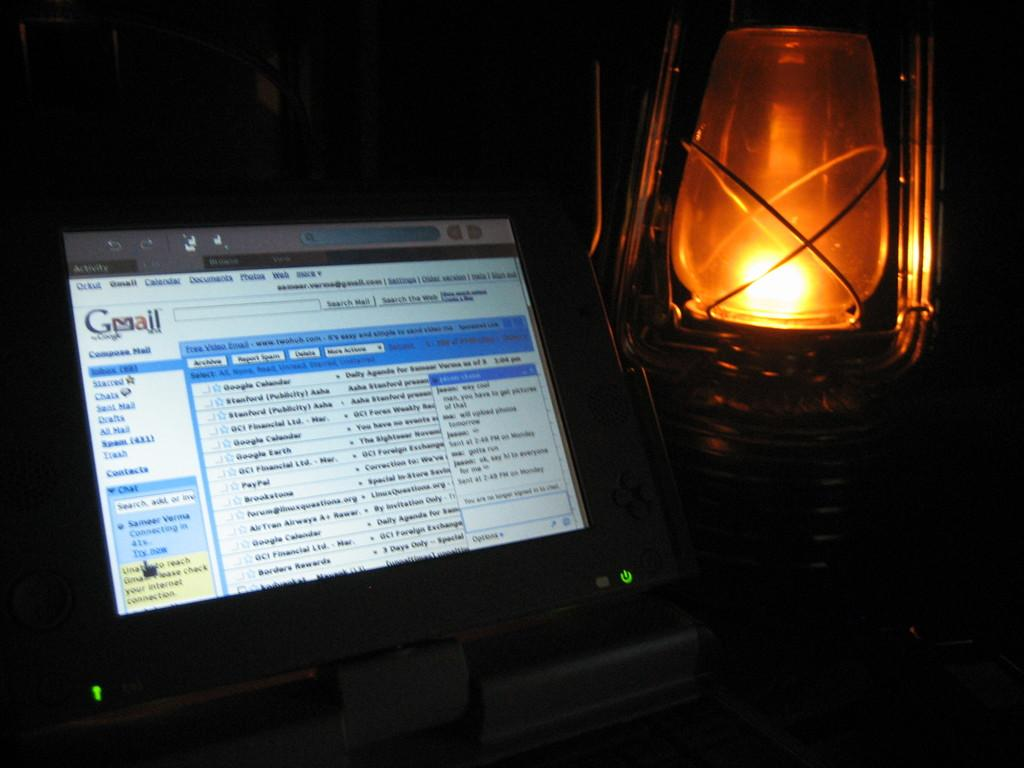What electronic device is visible in the image? There is a monitor in the image. What type of lighting source is present in the image? There is a lantern in the image. How would you describe the overall lighting in the image? The background of the image is dark. What decision was made by the person holding the lantern in the image? There is no person holding the lantern in the image, and therefore no decision can be attributed to them. 